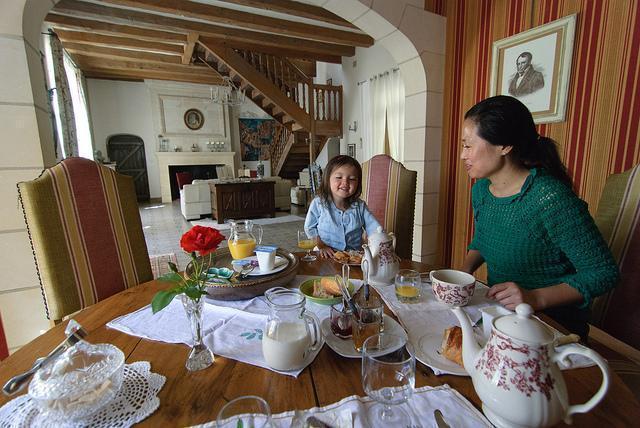Where does porcelain originally come from?
Select the accurate answer and provide explanation: 'Answer: answer
Rationale: rationale.'
Options: Italy, france, australia, china. Answer: china.
Rationale: The porcelain dishware in this kitchen scene is often called 'china'. this is also the place such dishware is associated with and originally came from. 